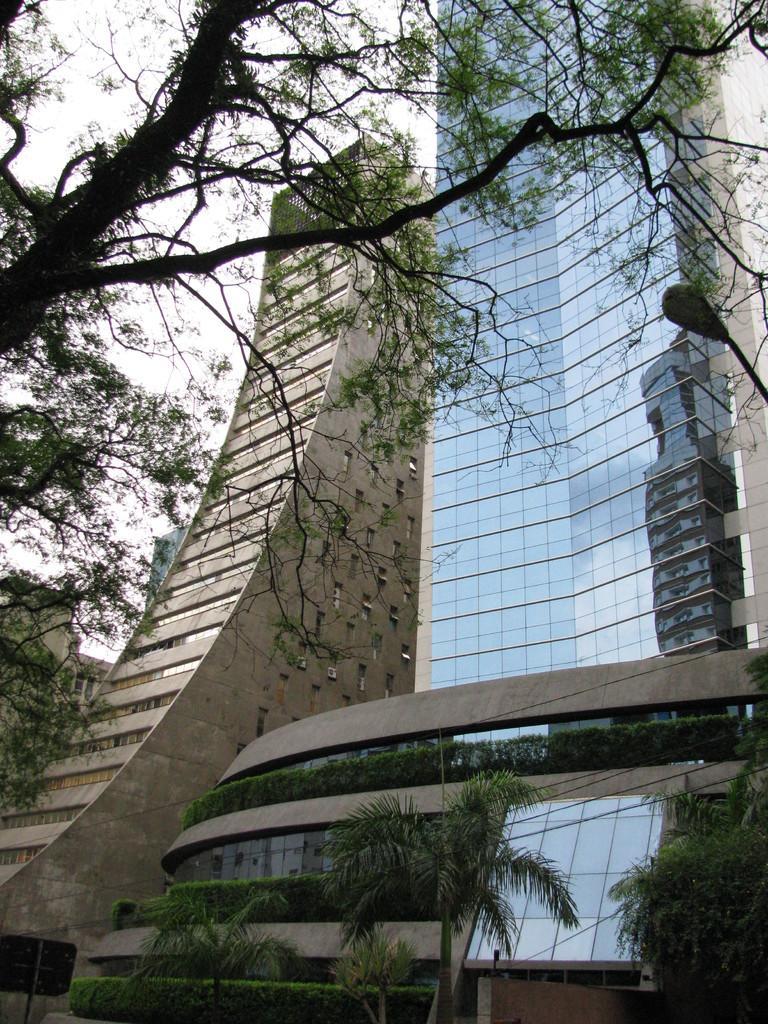Please provide a concise description of this image. In this picture I can see buildings, there are trees, and in the background there is the sky. 